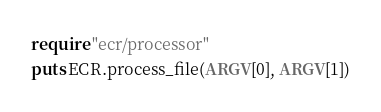Convert code to text. <code><loc_0><loc_0><loc_500><loc_500><_Crystal_>require "ecr/processor"
puts ECR.process_file(ARGV[0], ARGV[1])
</code> 